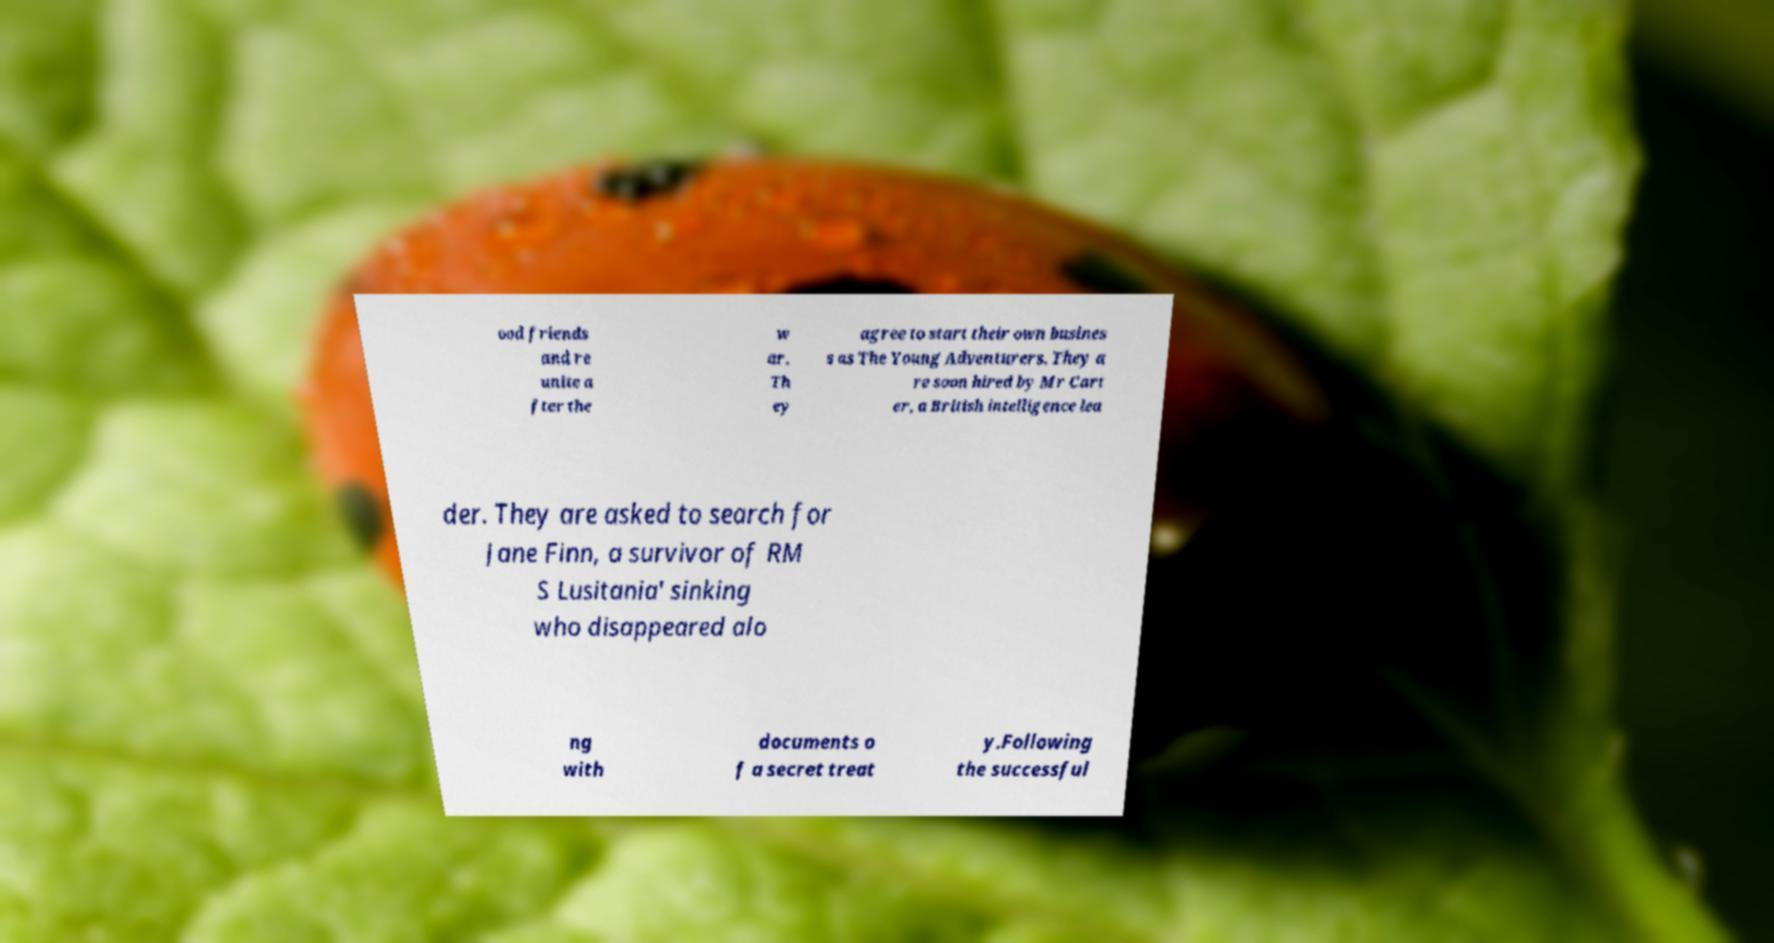Please read and relay the text visible in this image. What does it say? ood friends and re unite a fter the w ar. Th ey agree to start their own busines s as The Young Adventurers. They a re soon hired by Mr Cart er, a British intelligence lea der. They are asked to search for Jane Finn, a survivor of RM S Lusitania' sinking who disappeared alo ng with documents o f a secret treat y.Following the successful 